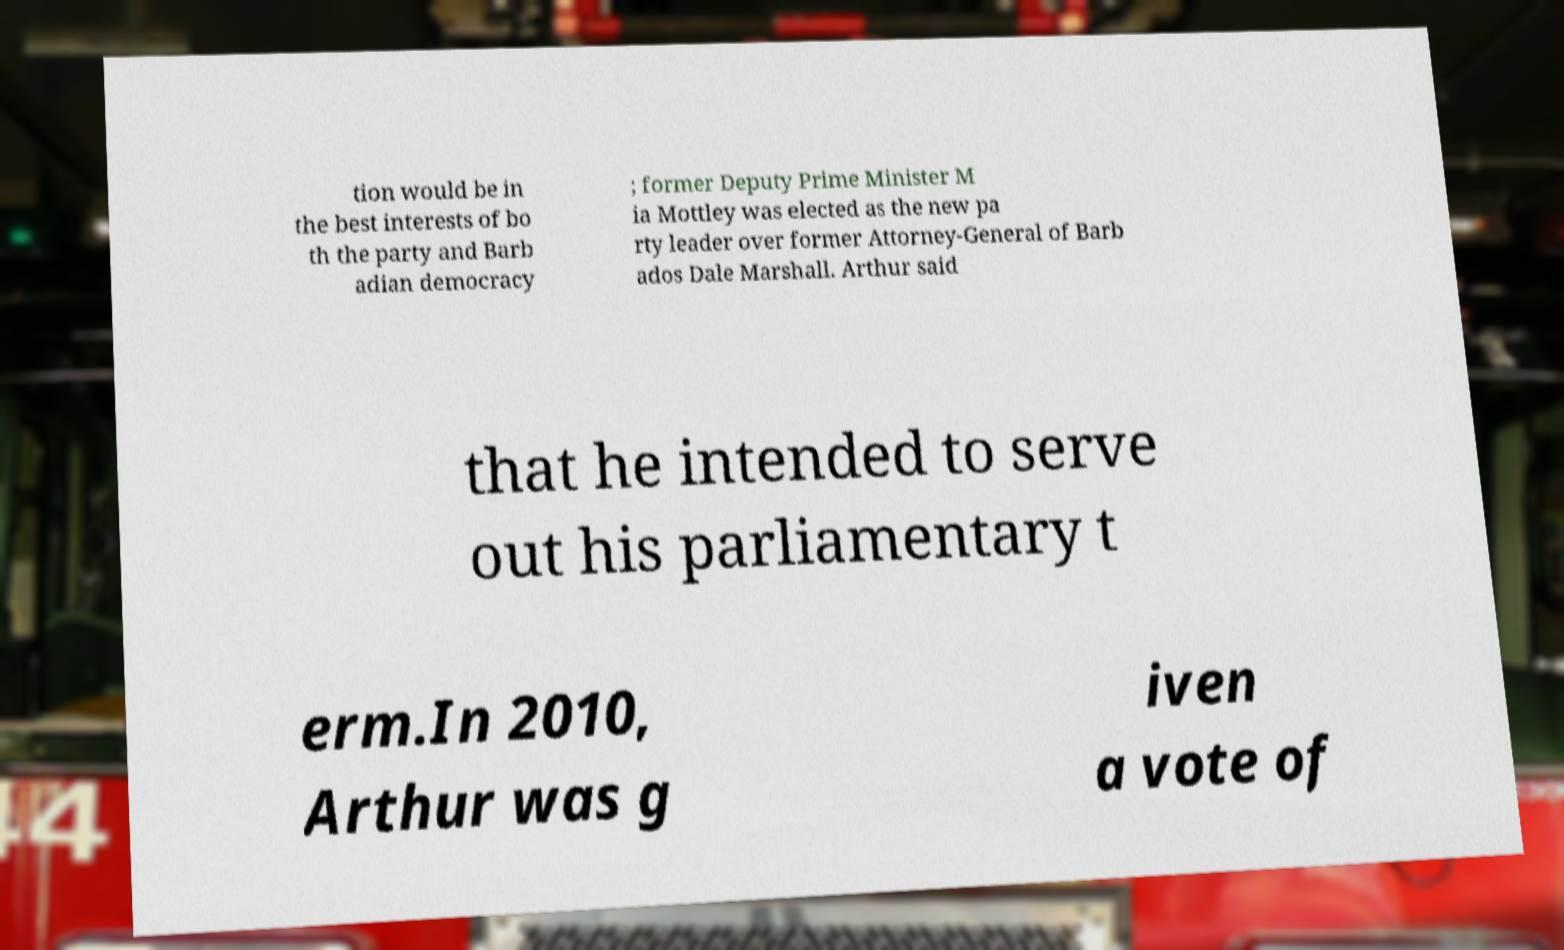Please identify and transcribe the text found in this image. tion would be in the best interests of bo th the party and Barb adian democracy ; former Deputy Prime Minister M ia Mottley was elected as the new pa rty leader over former Attorney-General of Barb ados Dale Marshall. Arthur said that he intended to serve out his parliamentary t erm.In 2010, Arthur was g iven a vote of 